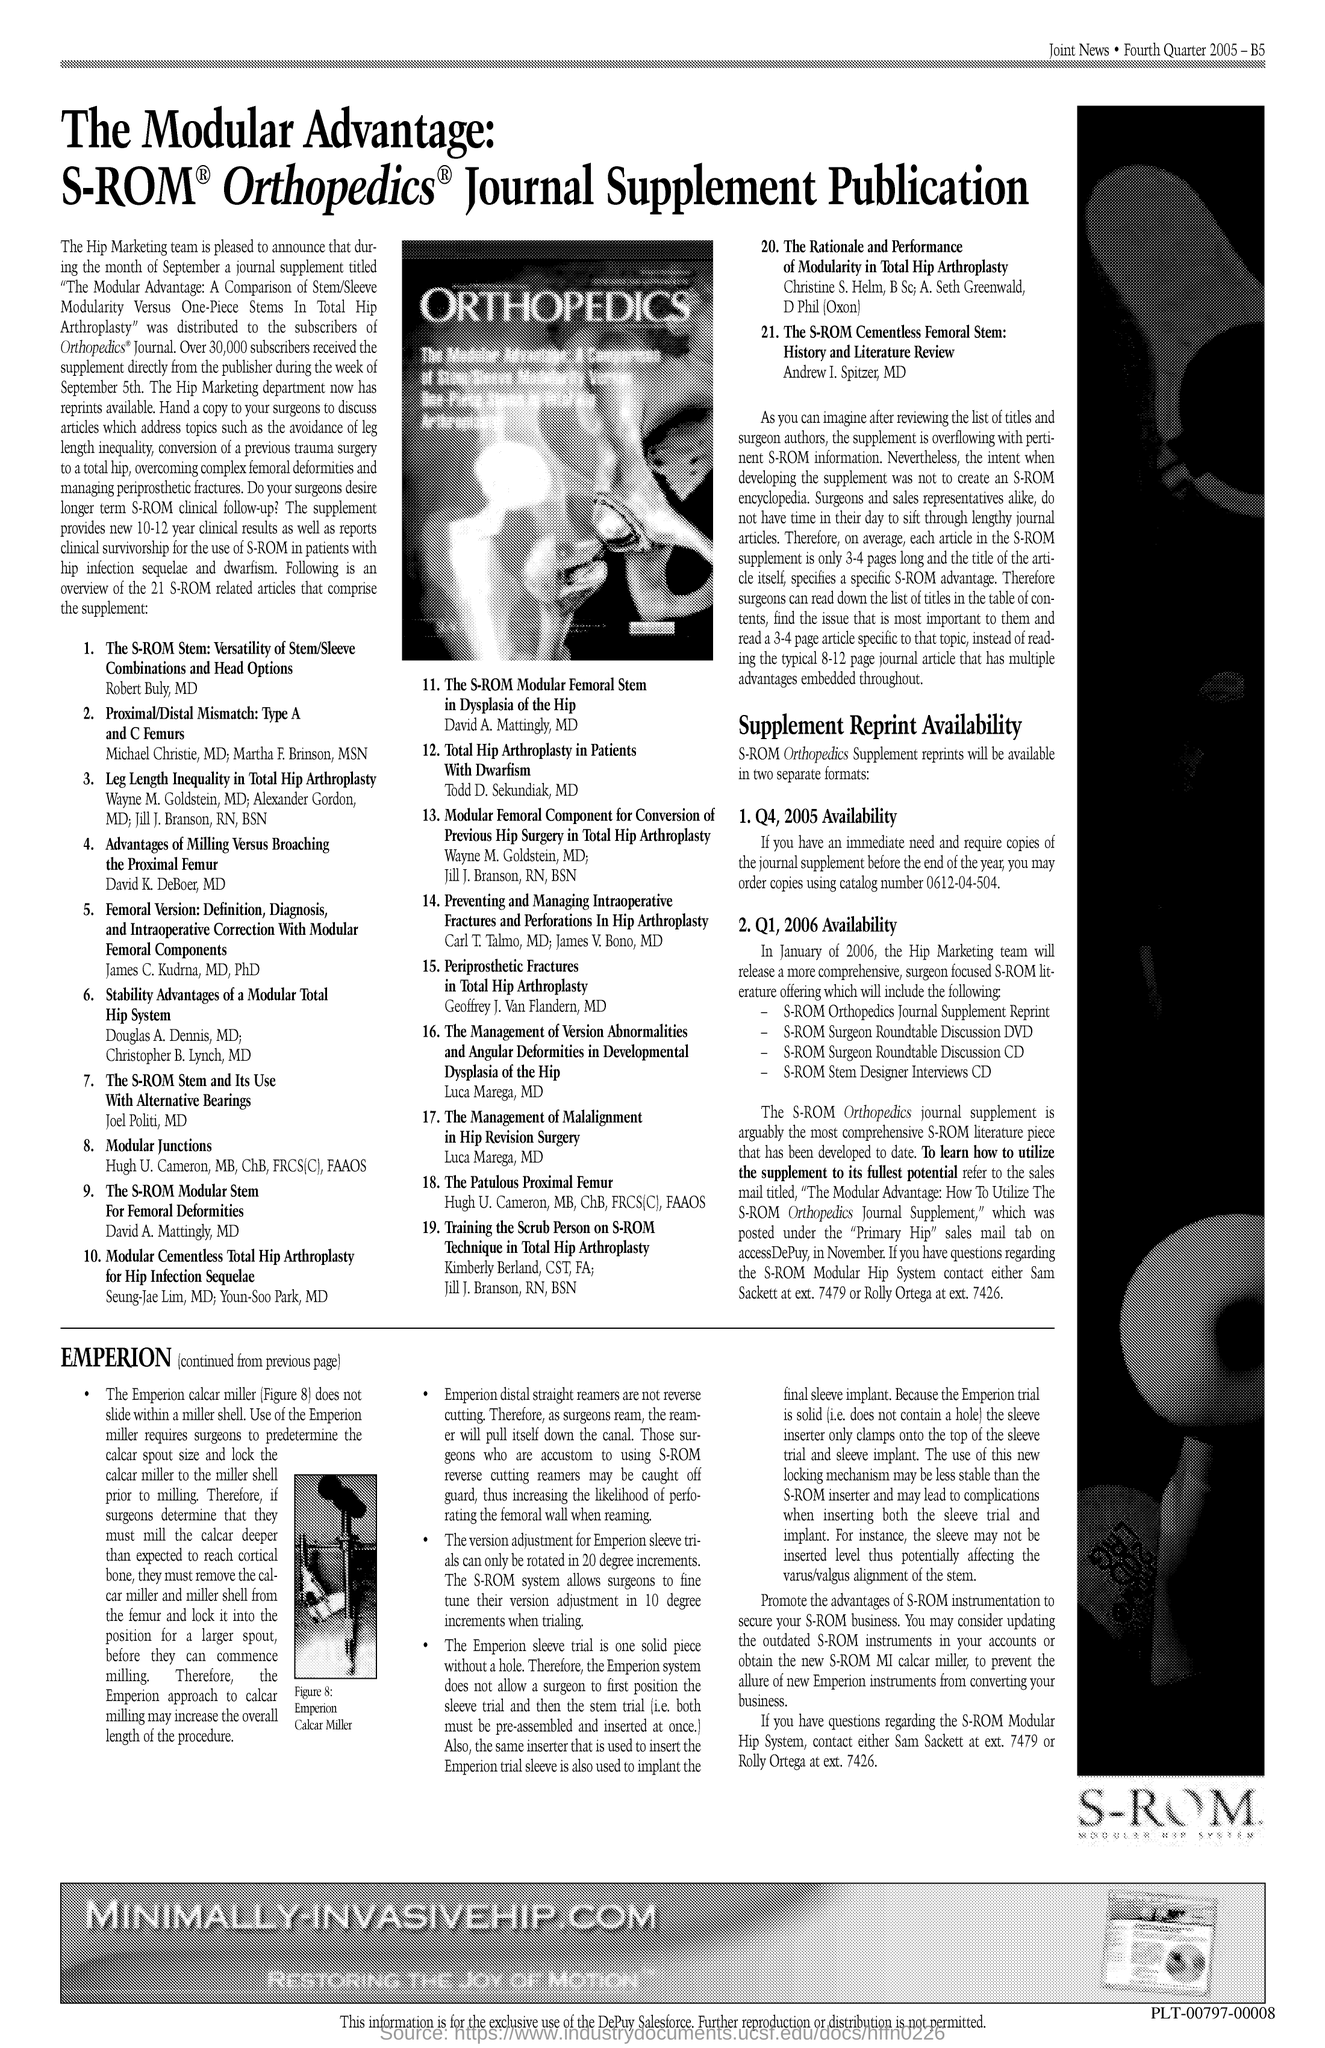List a handful of essential elements in this visual. The image contains text that reads "Orthopedics. 